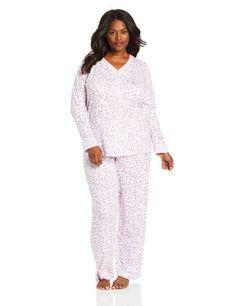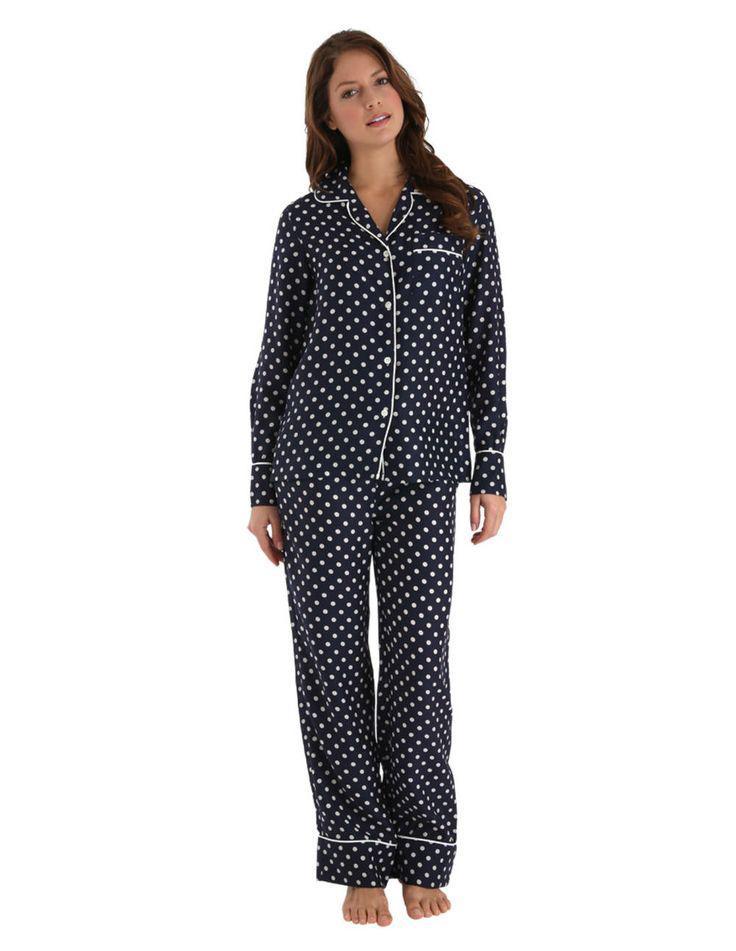The first image is the image on the left, the second image is the image on the right. Considering the images on both sides, is "Two pajama models are facing front and shown full length, each striking a pose similar to the other person." valid? Answer yes or no. Yes. The first image is the image on the left, the second image is the image on the right. For the images displayed, is the sentence "All models face forward and wear long pants, and at least one model wears dark pants with an all-over print." factually correct? Answer yes or no. Yes. 